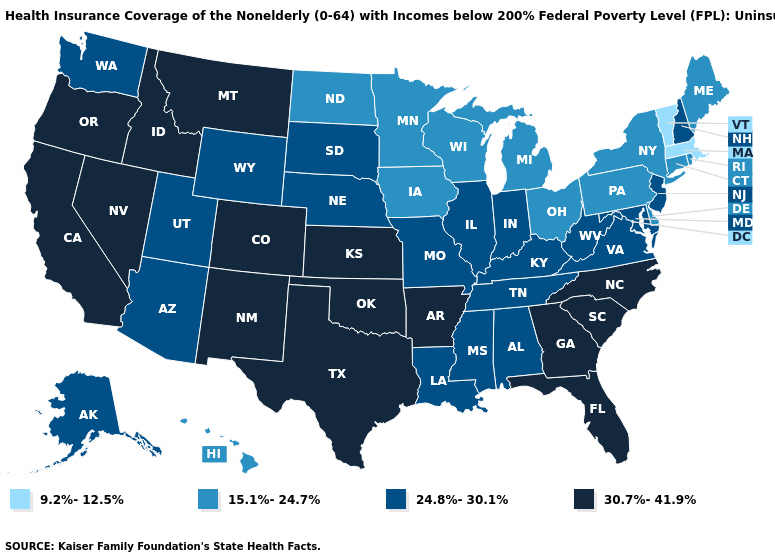Name the states that have a value in the range 9.2%-12.5%?
Answer briefly. Massachusetts, Vermont. What is the lowest value in states that border North Dakota?
Give a very brief answer. 15.1%-24.7%. What is the highest value in the South ?
Concise answer only. 30.7%-41.9%. What is the value of Minnesota?
Short answer required. 15.1%-24.7%. Which states have the lowest value in the MidWest?
Answer briefly. Iowa, Michigan, Minnesota, North Dakota, Ohio, Wisconsin. What is the highest value in the USA?
Write a very short answer. 30.7%-41.9%. Does the first symbol in the legend represent the smallest category?
Answer briefly. Yes. What is the highest value in the MidWest ?
Be succinct. 30.7%-41.9%. What is the value of Colorado?
Keep it brief. 30.7%-41.9%. What is the lowest value in the South?
Write a very short answer. 15.1%-24.7%. What is the lowest value in states that border Vermont?
Keep it brief. 9.2%-12.5%. Is the legend a continuous bar?
Quick response, please. No. Among the states that border Louisiana , which have the lowest value?
Write a very short answer. Mississippi. Is the legend a continuous bar?
Keep it brief. No. Which states have the lowest value in the USA?
Quick response, please. Massachusetts, Vermont. 